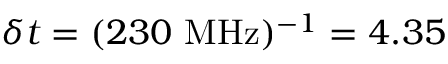<formula> <loc_0><loc_0><loc_500><loc_500>\delta t = ( 2 3 0 \ M H z ) ^ { - 1 } = 4 . 3 5</formula> 